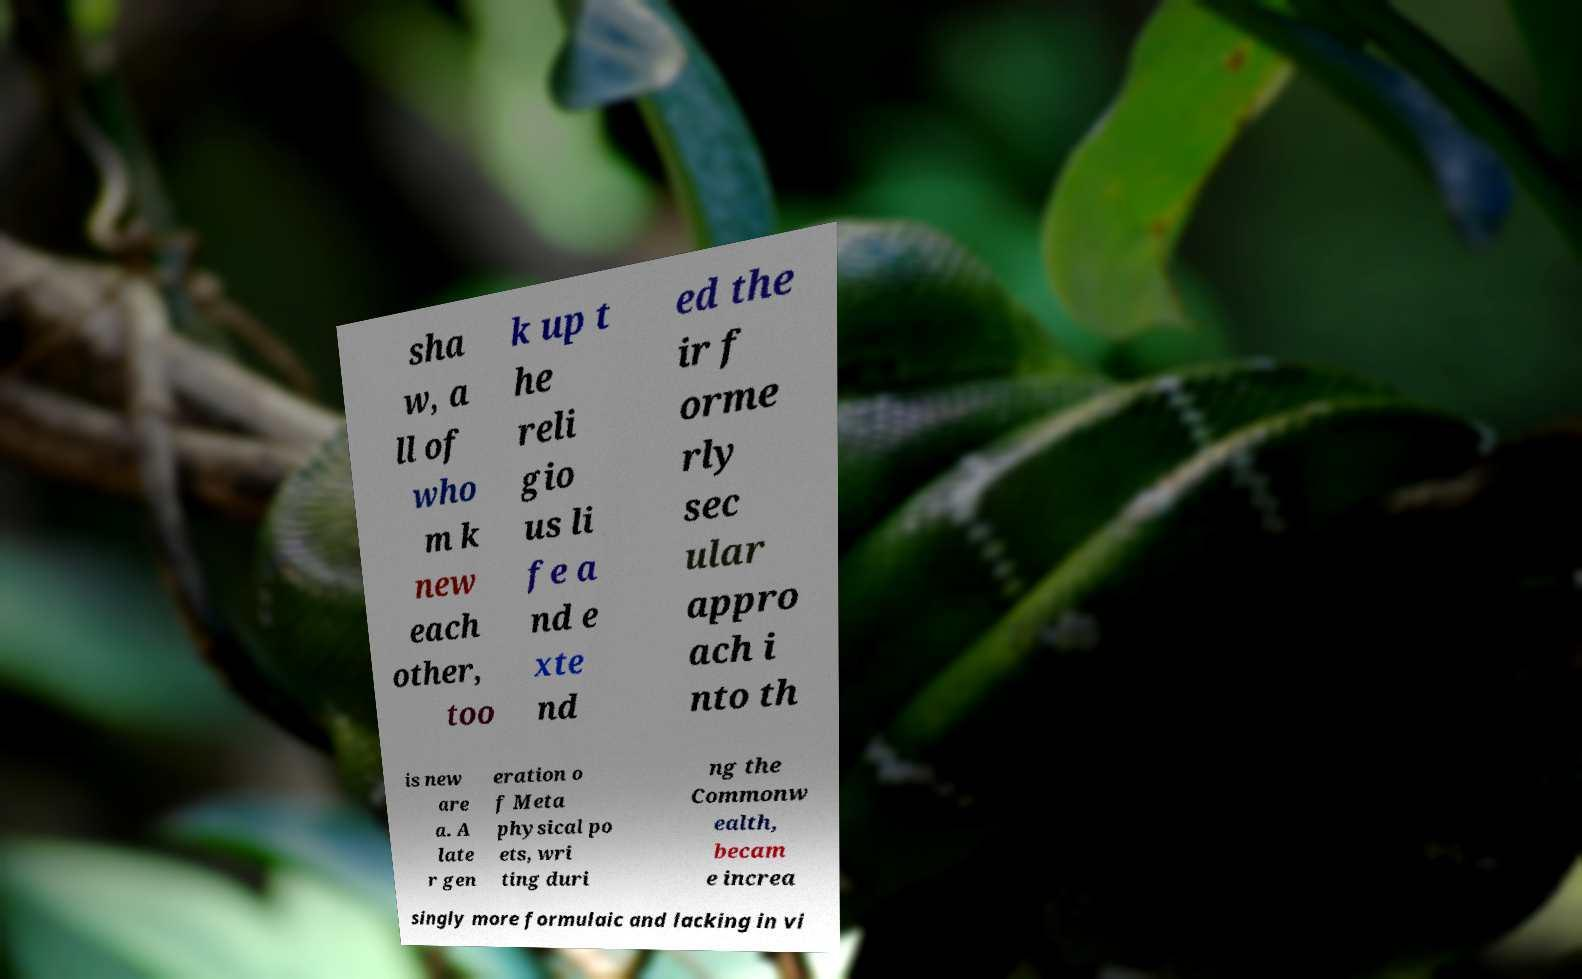Could you assist in decoding the text presented in this image and type it out clearly? sha w, a ll of who m k new each other, too k up t he reli gio us li fe a nd e xte nd ed the ir f orme rly sec ular appro ach i nto th is new are a. A late r gen eration o f Meta physical po ets, wri ting duri ng the Commonw ealth, becam e increa singly more formulaic and lacking in vi 